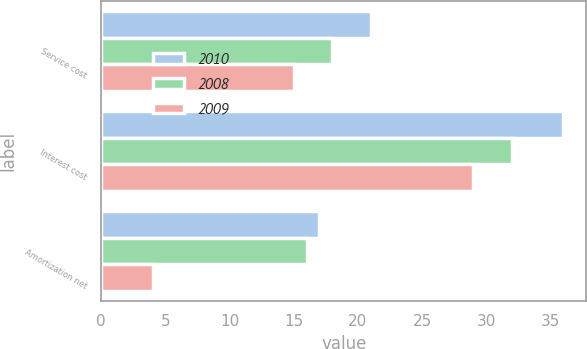Convert chart to OTSL. <chart><loc_0><loc_0><loc_500><loc_500><stacked_bar_chart><ecel><fcel>Service cost<fcel>Interest cost<fcel>Amortization net<nl><fcel>2010<fcel>21<fcel>36<fcel>17<nl><fcel>2008<fcel>18<fcel>32<fcel>16<nl><fcel>2009<fcel>15<fcel>29<fcel>4<nl></chart> 